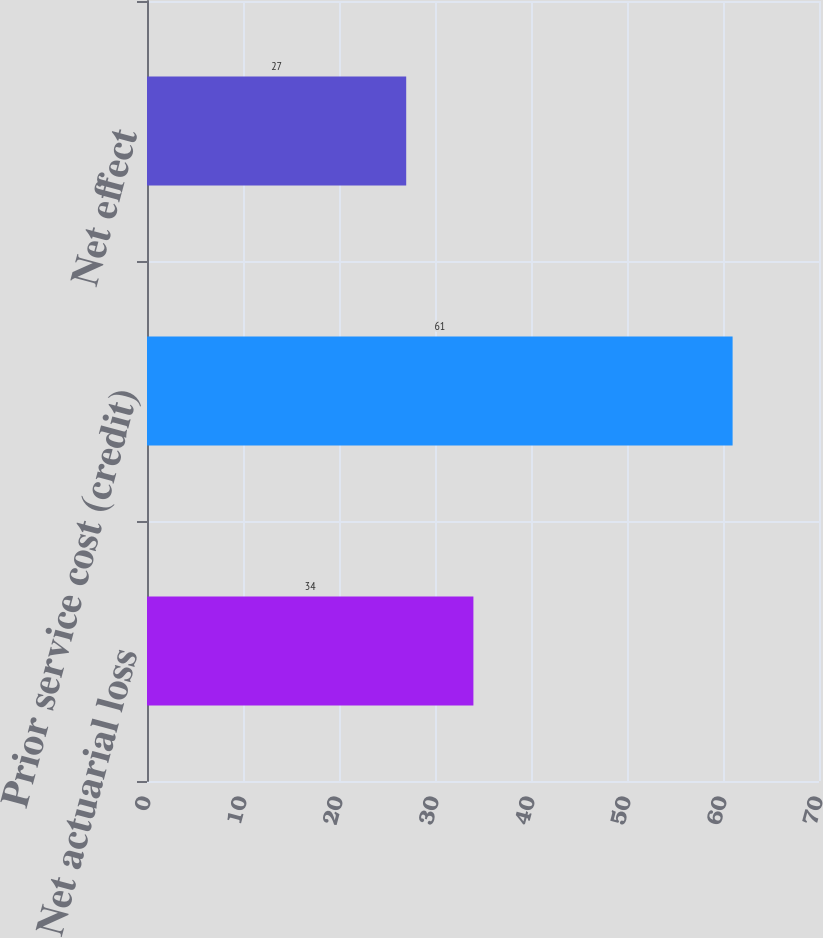Convert chart. <chart><loc_0><loc_0><loc_500><loc_500><bar_chart><fcel>Net actuarial loss<fcel>Prior service cost (credit)<fcel>Net effect<nl><fcel>34<fcel>61<fcel>27<nl></chart> 